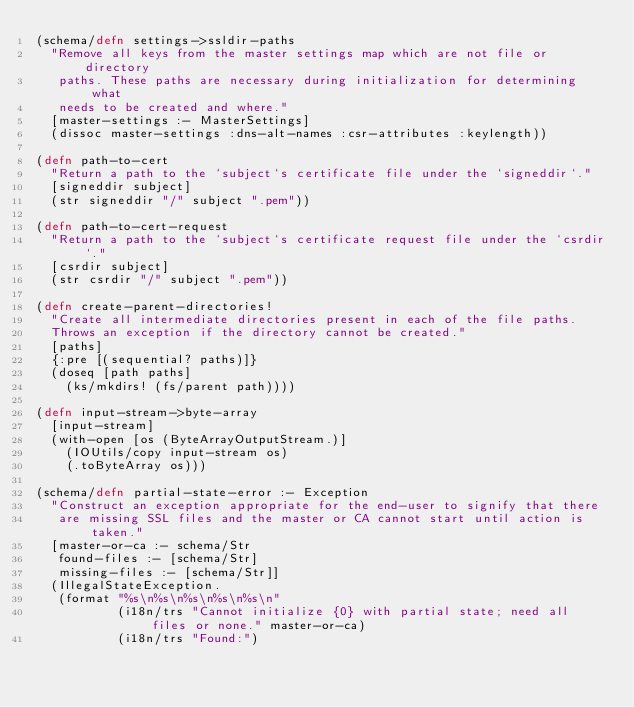<code> <loc_0><loc_0><loc_500><loc_500><_Clojure_>(schema/defn settings->ssldir-paths
  "Remove all keys from the master settings map which are not file or directory
   paths. These paths are necessary during initialization for determining what
   needs to be created and where."
  [master-settings :- MasterSettings]
  (dissoc master-settings :dns-alt-names :csr-attributes :keylength))

(defn path-to-cert
  "Return a path to the `subject`s certificate file under the `signeddir`."
  [signeddir subject]
  (str signeddir "/" subject ".pem"))

(defn path-to-cert-request
  "Return a path to the `subject`s certificate request file under the `csrdir`."
  [csrdir subject]
  (str csrdir "/" subject ".pem"))

(defn create-parent-directories!
  "Create all intermediate directories present in each of the file paths.
  Throws an exception if the directory cannot be created."
  [paths]
  {:pre [(sequential? paths)]}
  (doseq [path paths]
    (ks/mkdirs! (fs/parent path))))

(defn input-stream->byte-array
  [input-stream]
  (with-open [os (ByteArrayOutputStream.)]
    (IOUtils/copy input-stream os)
    (.toByteArray os)))

(schema/defn partial-state-error :- Exception
  "Construct an exception appropriate for the end-user to signify that there
   are missing SSL files and the master or CA cannot start until action is taken."
  [master-or-ca :- schema/Str
   found-files :- [schema/Str]
   missing-files :- [schema/Str]]
  (IllegalStateException.
   (format "%s\n%s\n%s\n%s\n%s\n"
           (i18n/trs "Cannot initialize {0} with partial state; need all files or none." master-or-ca)
           (i18n/trs "Found:")</code> 